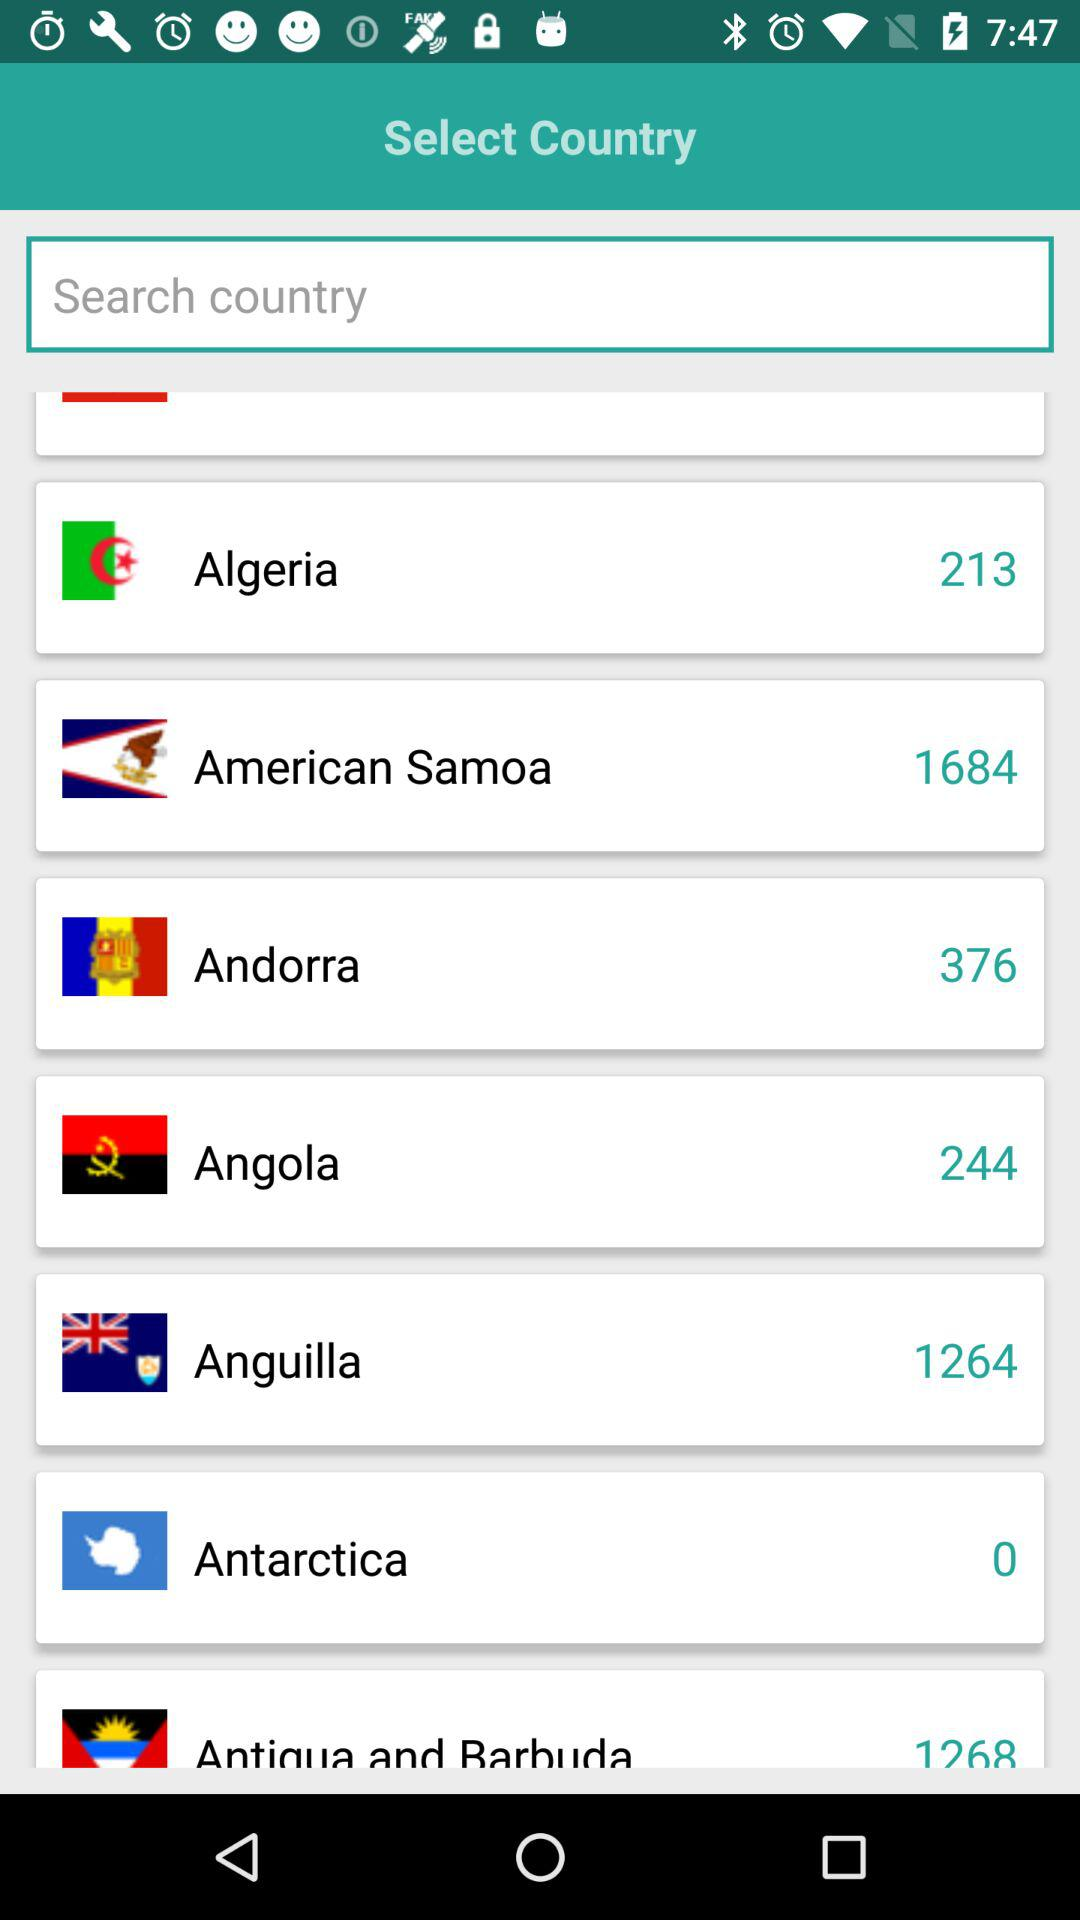What is Anguilla's country code? Anguilla's country code is 1264. 